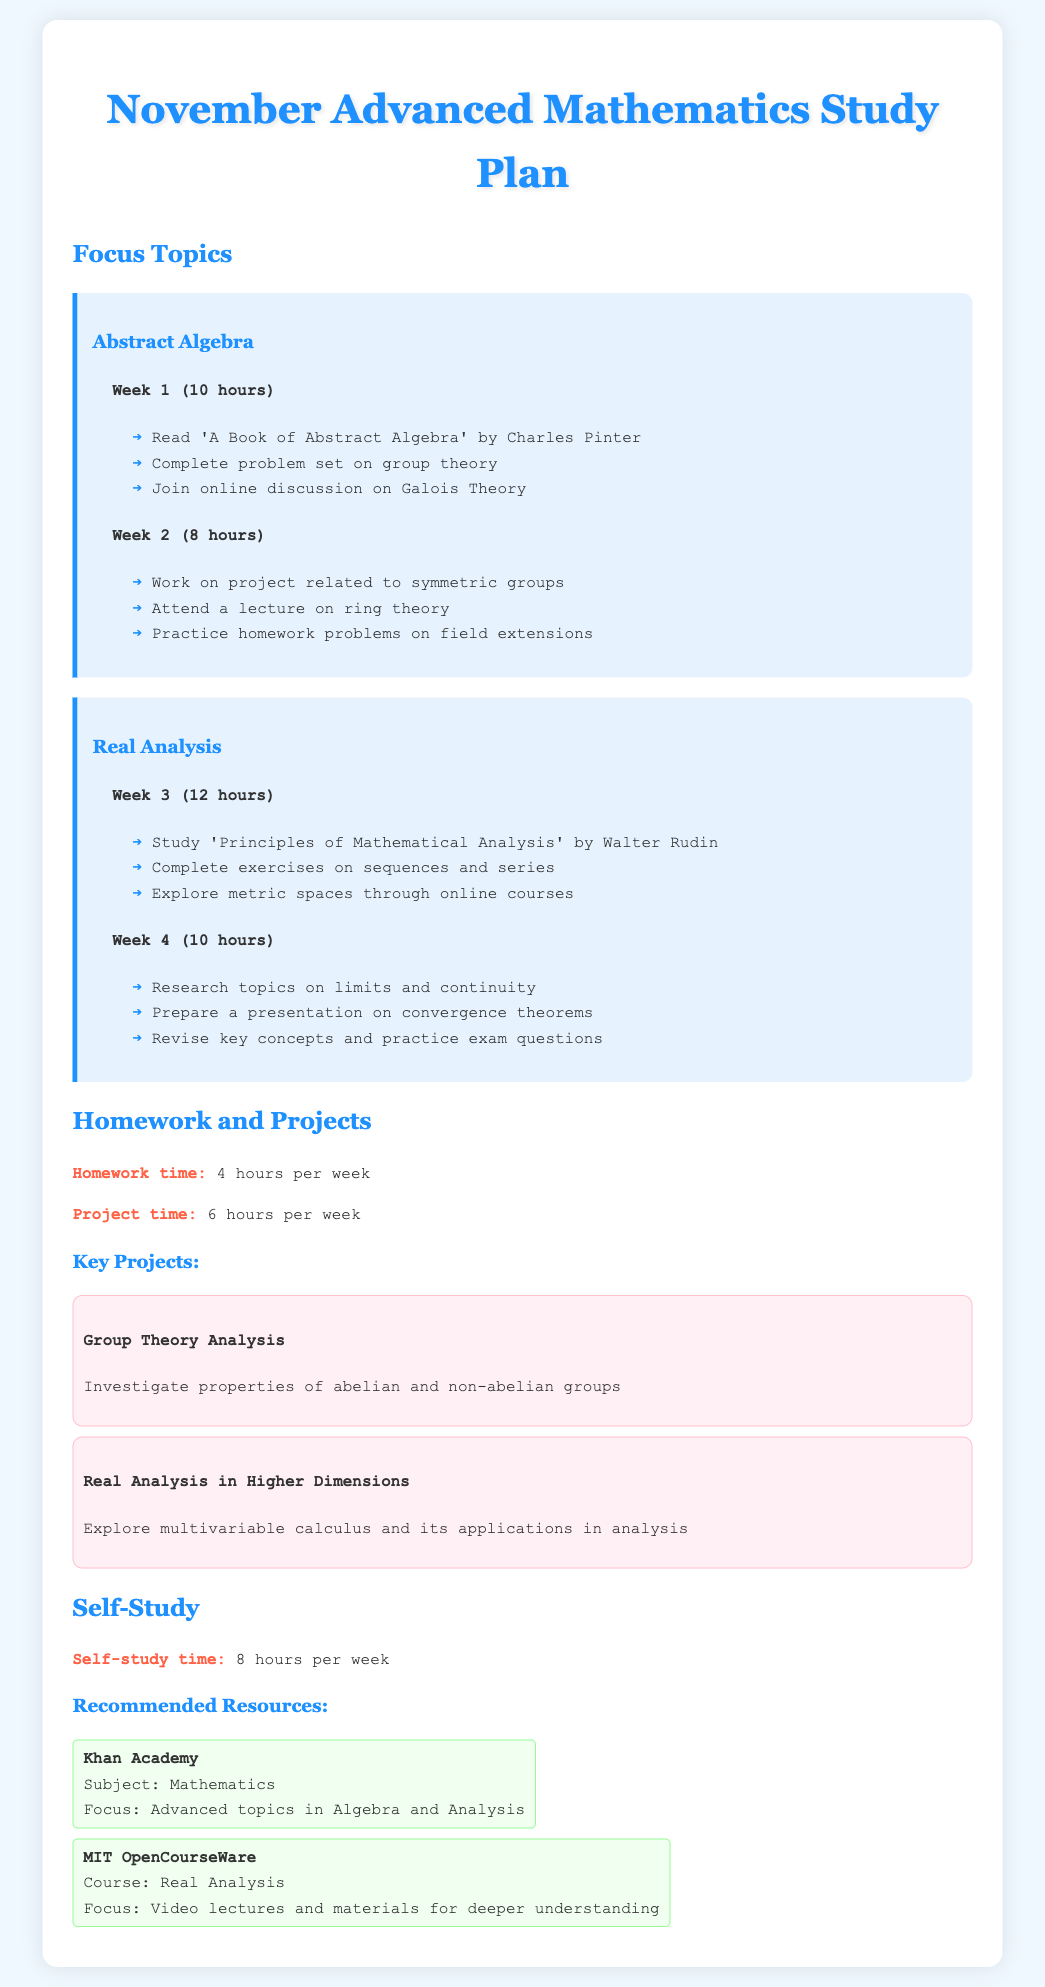What is the total study time for Week 1 of Abstract Algebra? The total study time for Week 1 is specified in the document as 10 hours.
Answer: 10 hours What book is recommended for Real Analysis? The document mentions 'Principles of Mathematical Analysis' by Walter Rudin as the study resource for Real Analysis.
Answer: Principles of Mathematical Analysis How many hours per week are allocated for homework? The document clearly states that 4 hours per week are allocated for homework.
Answer: 4 hours What focus topic is covered in Week 2? The focus topic for Week 2 is Abstract Algebra, specifically related to symmetric groups according to the document.
Answer: Abstract Algebra How many total hours are dedicated to self-study per week? The document indicates that 8 hours are allocated for self-study each week.
Answer: 8 hours What is the title of the key project related to Group Theory? The document lists 'Group Theory Analysis' as a key project focusing on group properties.
Answer: Group Theory Analysis Which online platform is recommended for advanced mathematics topics? The document recommends Khan Academy for advanced topics in Algebra and Analysis.
Answer: Khan Academy In which week do students prepare a presentation on convergence theorems? According to the document, the preparation for the presentation on convergence theorems occurs in Week 4.
Answer: Week 4 What is the focus of the project titled "Real Analysis in Higher Dimensions"? The document mentions the project aims to explore multivariable calculus and its applications in analysis.
Answer: Multivariable calculus and its applications in analysis 